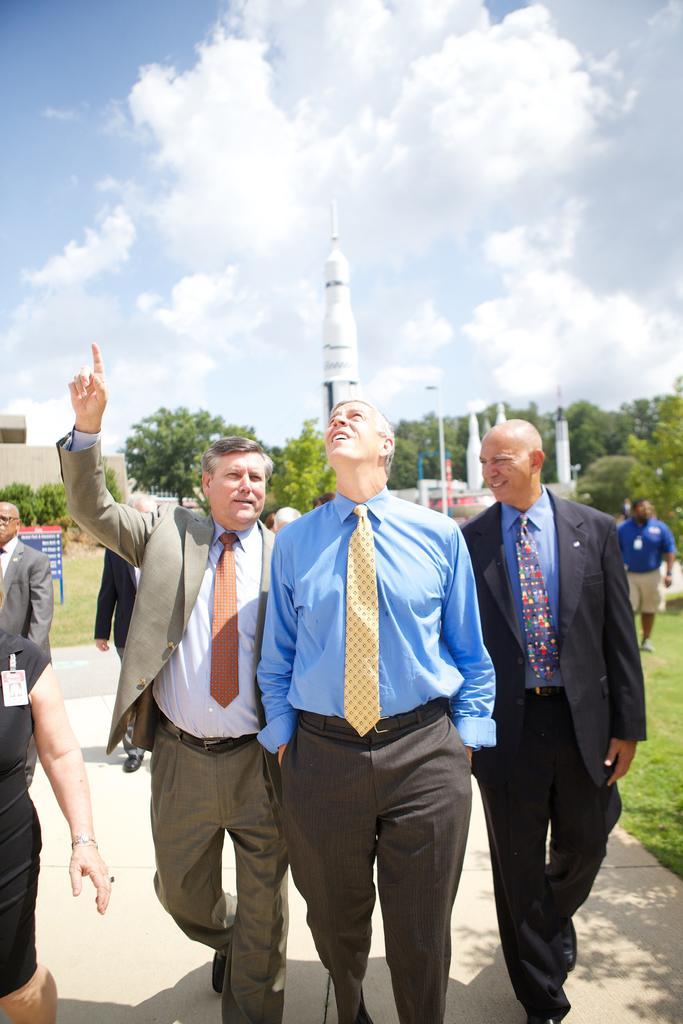Describe this image in one or two sentences. In this picture there are three old man walking and looking to sky. Behind there is white color rocket and some trees around it. 